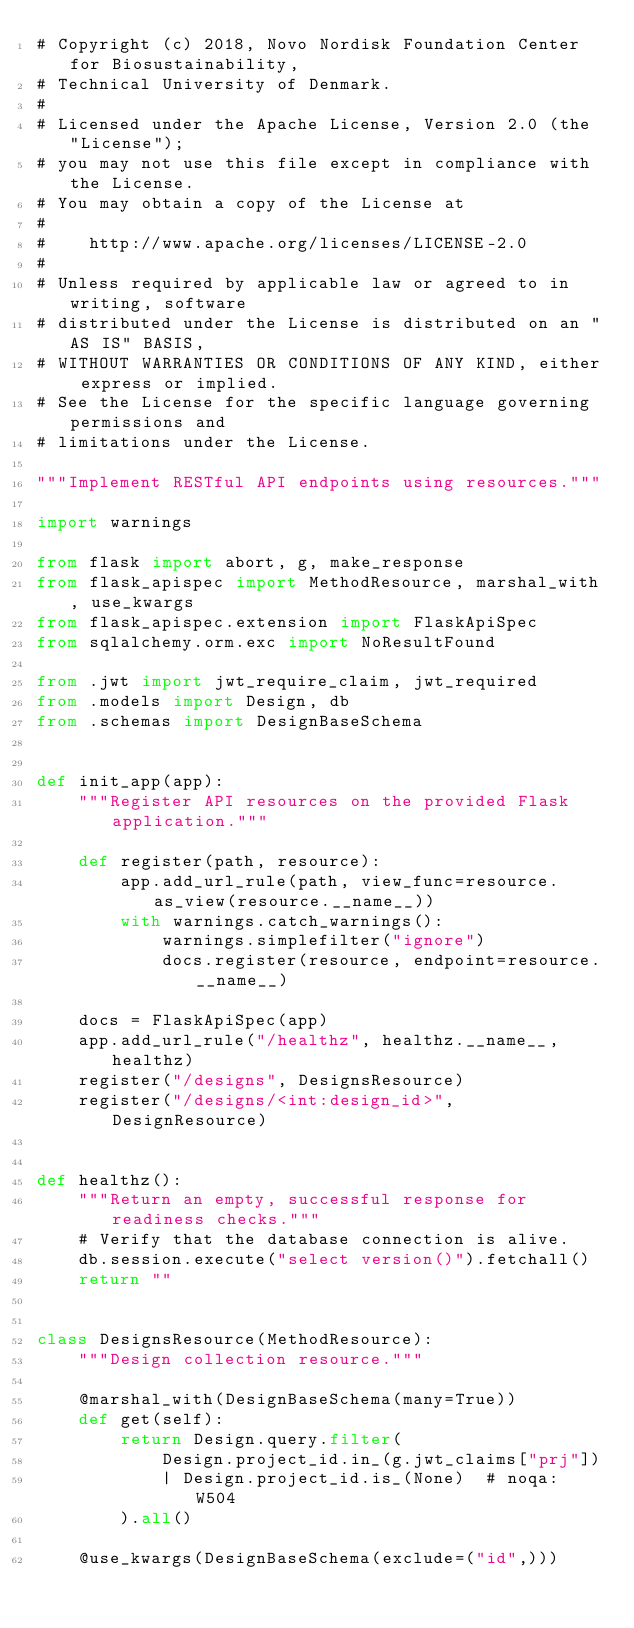Convert code to text. <code><loc_0><loc_0><loc_500><loc_500><_Python_># Copyright (c) 2018, Novo Nordisk Foundation Center for Biosustainability,
# Technical University of Denmark.
#
# Licensed under the Apache License, Version 2.0 (the "License");
# you may not use this file except in compliance with the License.
# You may obtain a copy of the License at
#
#    http://www.apache.org/licenses/LICENSE-2.0
#
# Unless required by applicable law or agreed to in writing, software
# distributed under the License is distributed on an "AS IS" BASIS,
# WITHOUT WARRANTIES OR CONDITIONS OF ANY KIND, either express or implied.
# See the License for the specific language governing permissions and
# limitations under the License.

"""Implement RESTful API endpoints using resources."""

import warnings

from flask import abort, g, make_response
from flask_apispec import MethodResource, marshal_with, use_kwargs
from flask_apispec.extension import FlaskApiSpec
from sqlalchemy.orm.exc import NoResultFound

from .jwt import jwt_require_claim, jwt_required
from .models import Design, db
from .schemas import DesignBaseSchema


def init_app(app):
    """Register API resources on the provided Flask application."""

    def register(path, resource):
        app.add_url_rule(path, view_func=resource.as_view(resource.__name__))
        with warnings.catch_warnings():
            warnings.simplefilter("ignore")
            docs.register(resource, endpoint=resource.__name__)

    docs = FlaskApiSpec(app)
    app.add_url_rule("/healthz", healthz.__name__, healthz)
    register("/designs", DesignsResource)
    register("/designs/<int:design_id>", DesignResource)


def healthz():
    """Return an empty, successful response for readiness checks."""
    # Verify that the database connection is alive.
    db.session.execute("select version()").fetchall()
    return ""


class DesignsResource(MethodResource):
    """Design collection resource."""

    @marshal_with(DesignBaseSchema(many=True))
    def get(self):
        return Design.query.filter(
            Design.project_id.in_(g.jwt_claims["prj"])
            | Design.project_id.is_(None)  # noqa: W504
        ).all()

    @use_kwargs(DesignBaseSchema(exclude=("id",)))</code> 